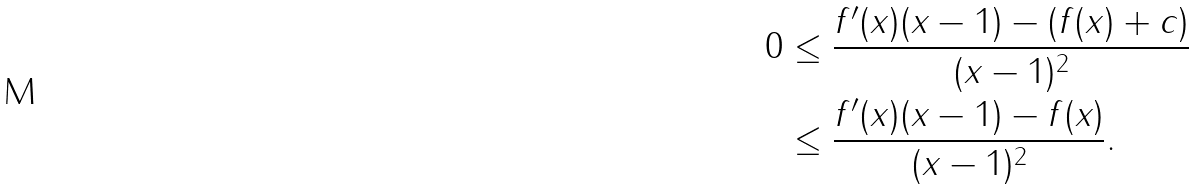<formula> <loc_0><loc_0><loc_500><loc_500>0 & \leq \frac { f ^ { \prime } ( x ) ( x - 1 ) - ( f ( x ) + c ) } { ( x - 1 ) ^ { 2 } } \\ & \leq \frac { f ^ { \prime } ( x ) ( x - 1 ) - f ( x ) } { ( x - 1 ) ^ { 2 } } .</formula> 